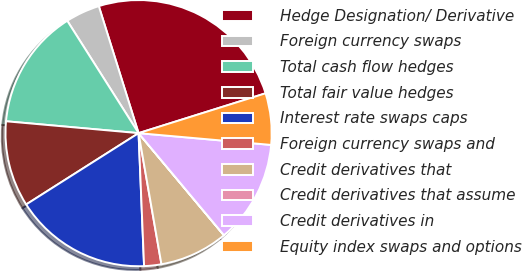<chart> <loc_0><loc_0><loc_500><loc_500><pie_chart><fcel>Hedge Designation/ Derivative<fcel>Foreign currency swaps<fcel>Total cash flow hedges<fcel>Total fair value hedges<fcel>Interest rate swaps caps<fcel>Foreign currency swaps and<fcel>Credit derivatives that<fcel>Credit derivatives that assume<fcel>Credit derivatives in<fcel>Equity index swaps and options<nl><fcel>24.99%<fcel>4.17%<fcel>14.58%<fcel>10.42%<fcel>16.66%<fcel>2.09%<fcel>8.33%<fcel>0.01%<fcel>12.5%<fcel>6.25%<nl></chart> 